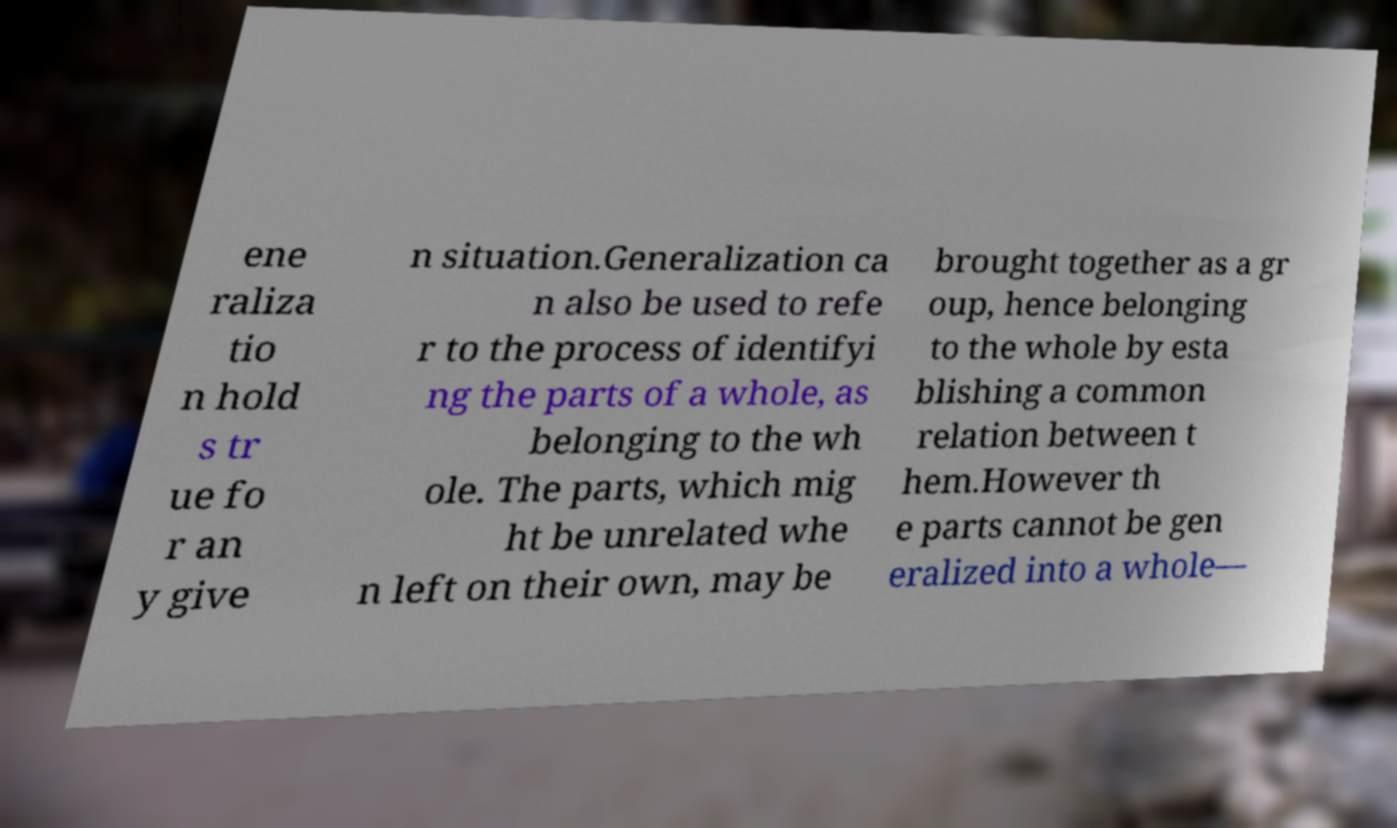Could you assist in decoding the text presented in this image and type it out clearly? ene raliza tio n hold s tr ue fo r an y give n situation.Generalization ca n also be used to refe r to the process of identifyi ng the parts of a whole, as belonging to the wh ole. The parts, which mig ht be unrelated whe n left on their own, may be brought together as a gr oup, hence belonging to the whole by esta blishing a common relation between t hem.However th e parts cannot be gen eralized into a whole— 